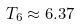<formula> <loc_0><loc_0><loc_500><loc_500>T _ { 6 } \approx 6 . 3 7</formula> 